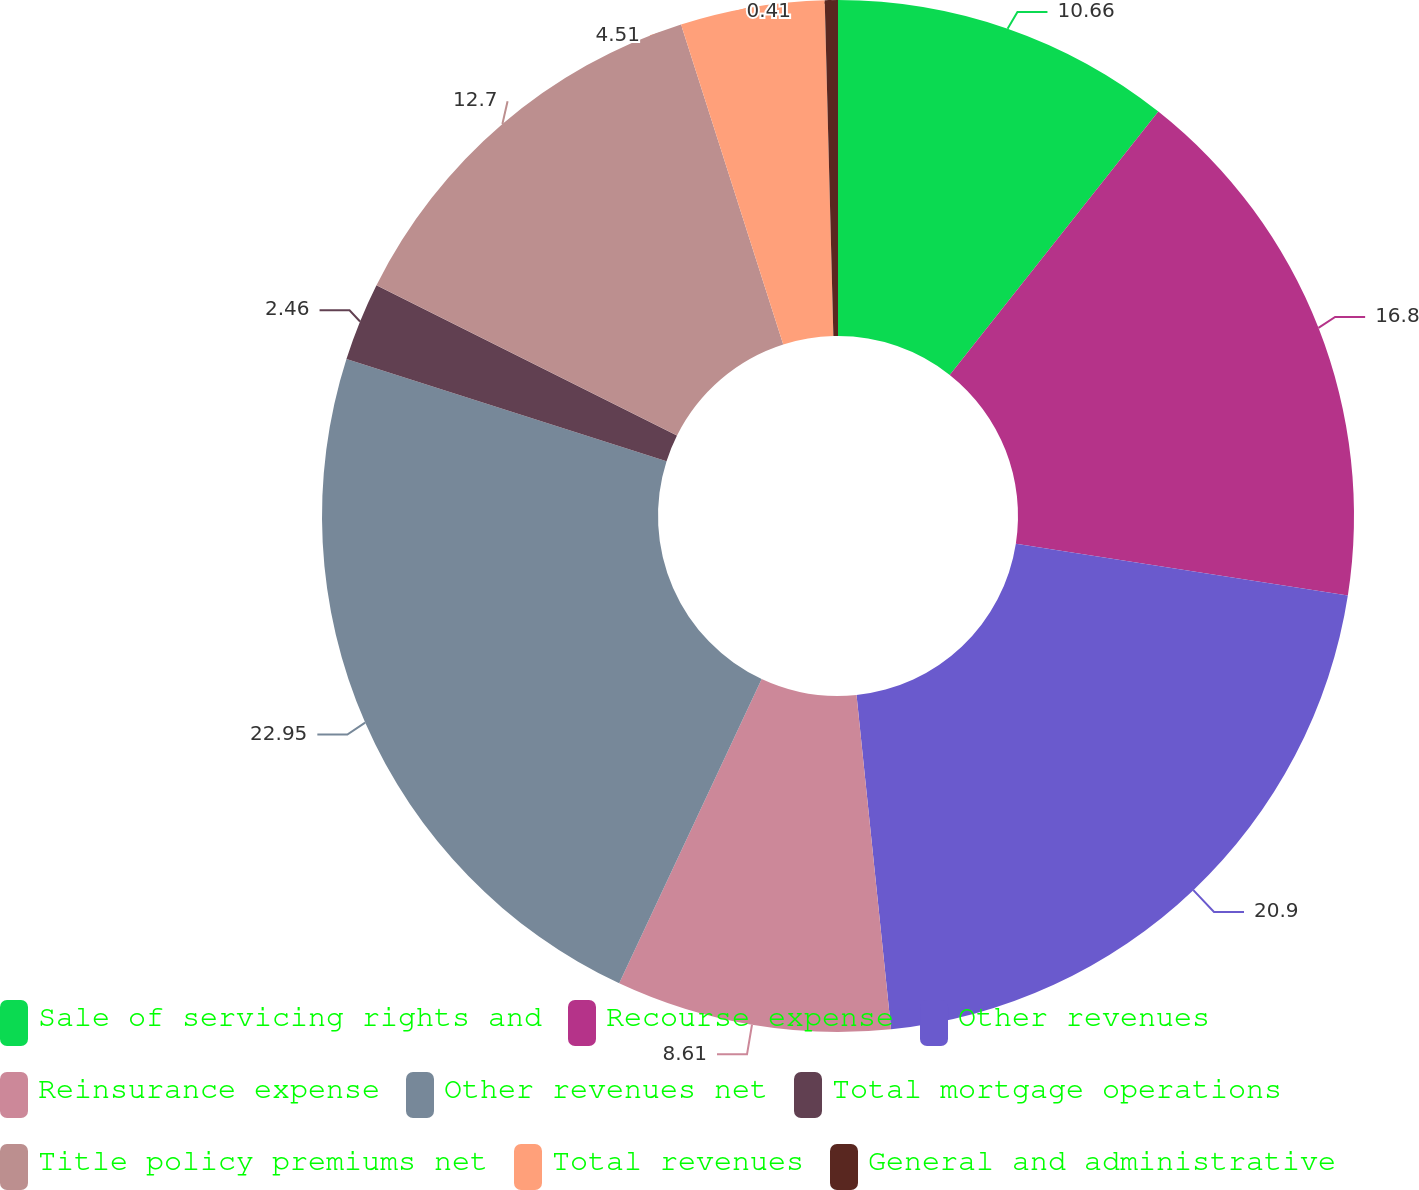<chart> <loc_0><loc_0><loc_500><loc_500><pie_chart><fcel>Sale of servicing rights and<fcel>Recourse expense<fcel>Other revenues<fcel>Reinsurance expense<fcel>Other revenues net<fcel>Total mortgage operations<fcel>Title policy premiums net<fcel>Total revenues<fcel>General and administrative<nl><fcel>10.66%<fcel>16.8%<fcel>20.9%<fcel>8.61%<fcel>22.95%<fcel>2.46%<fcel>12.7%<fcel>4.51%<fcel>0.41%<nl></chart> 